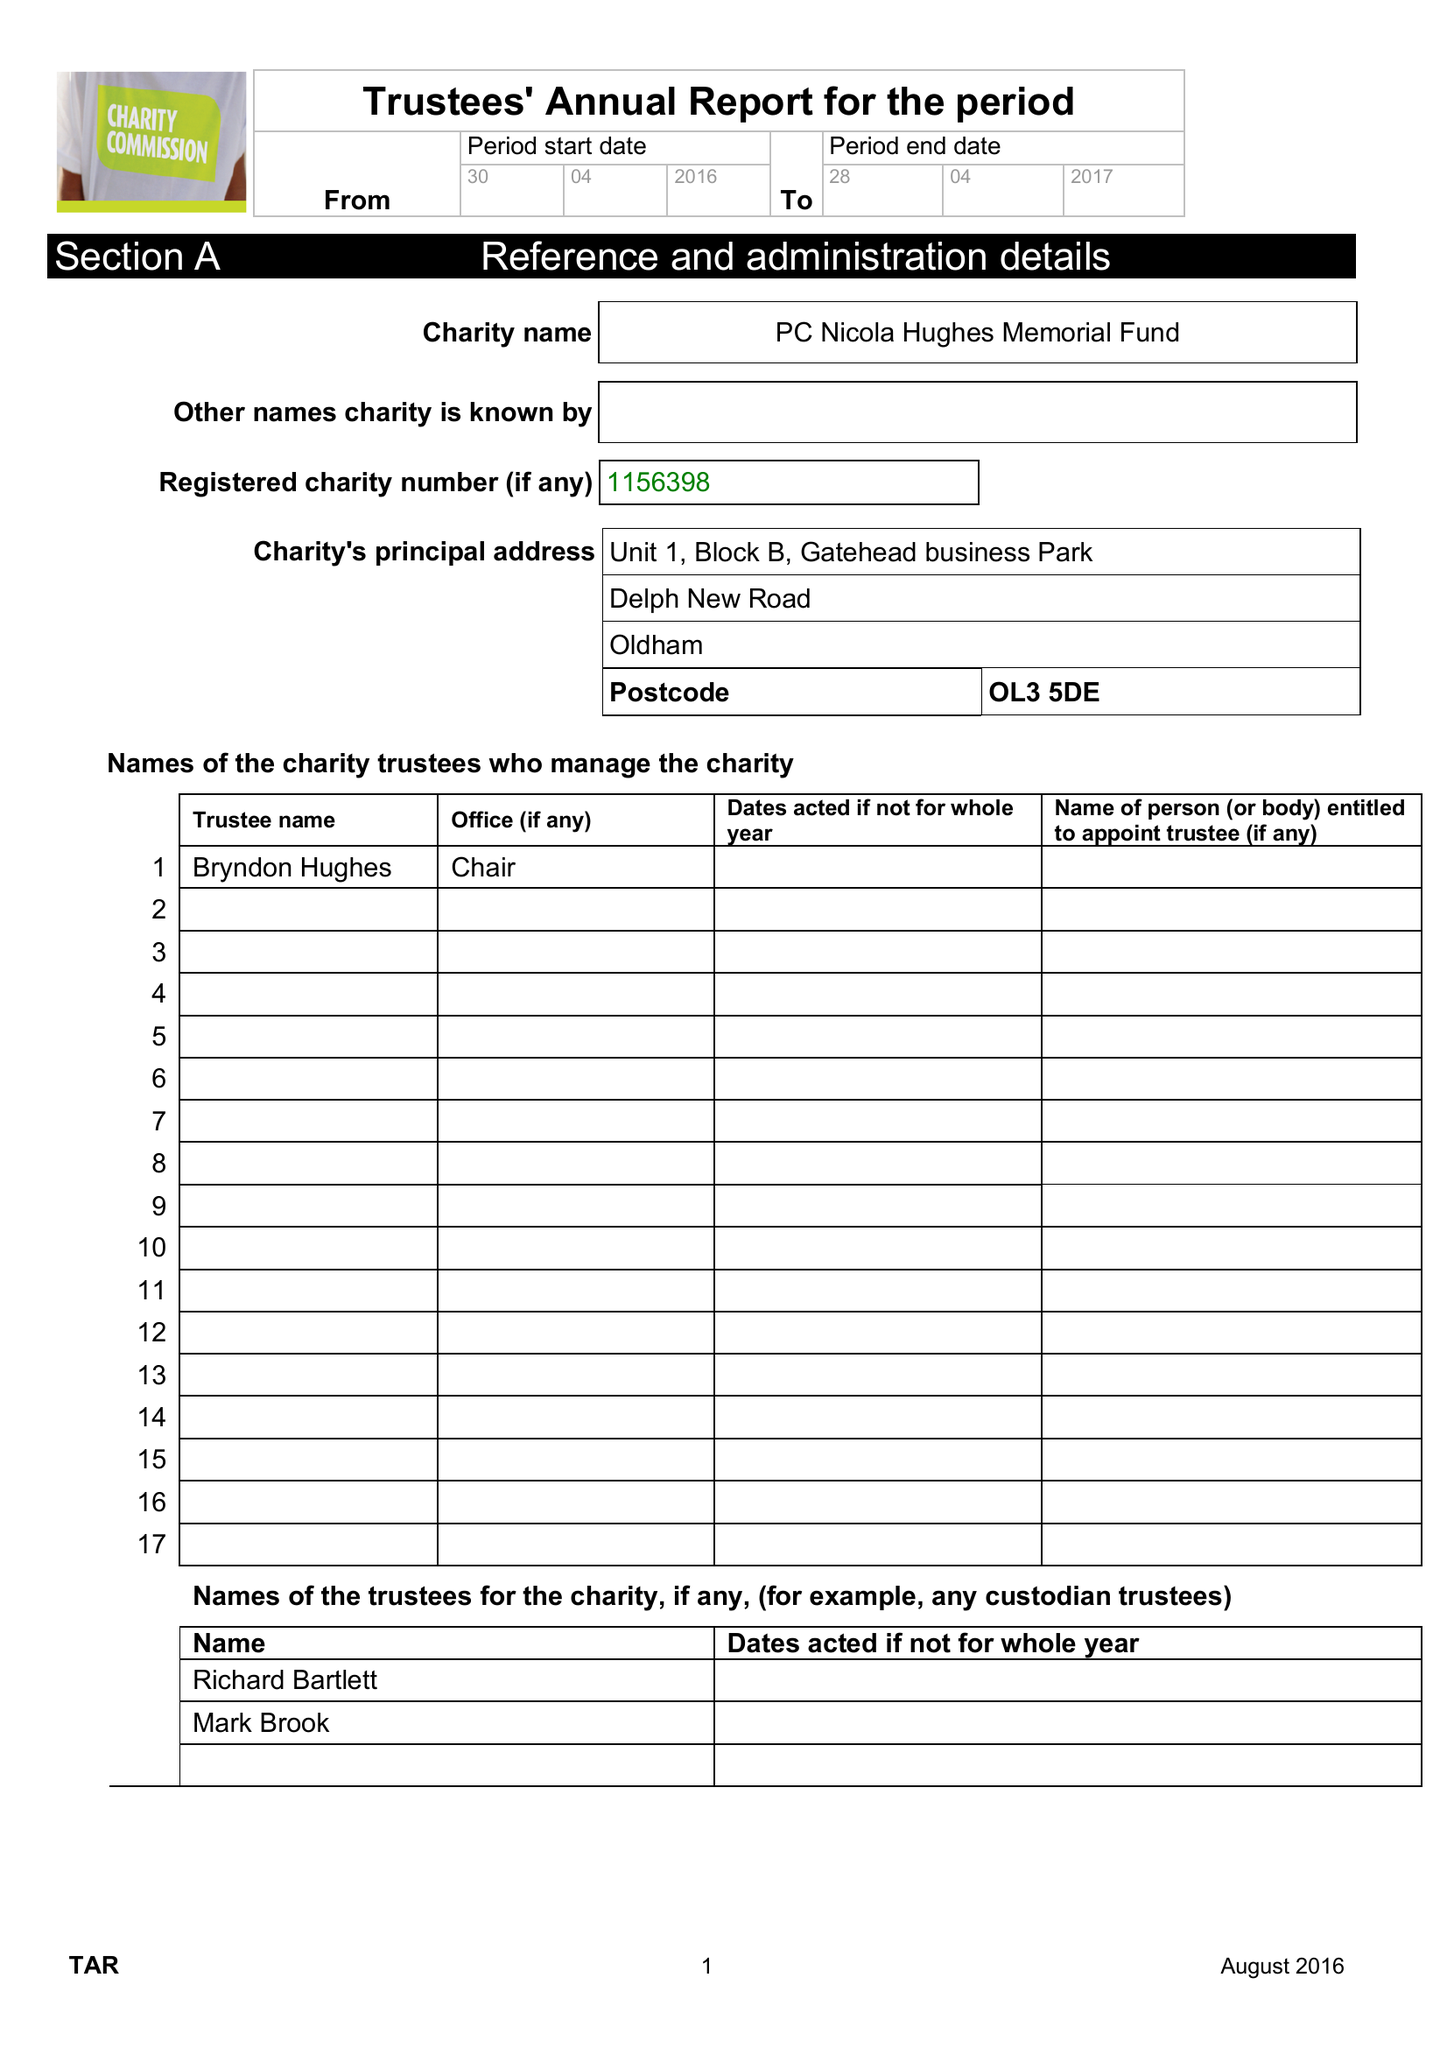What is the value for the charity_name?
Answer the question using a single word or phrase. Pc Nicola Hughes Memorial Fund 